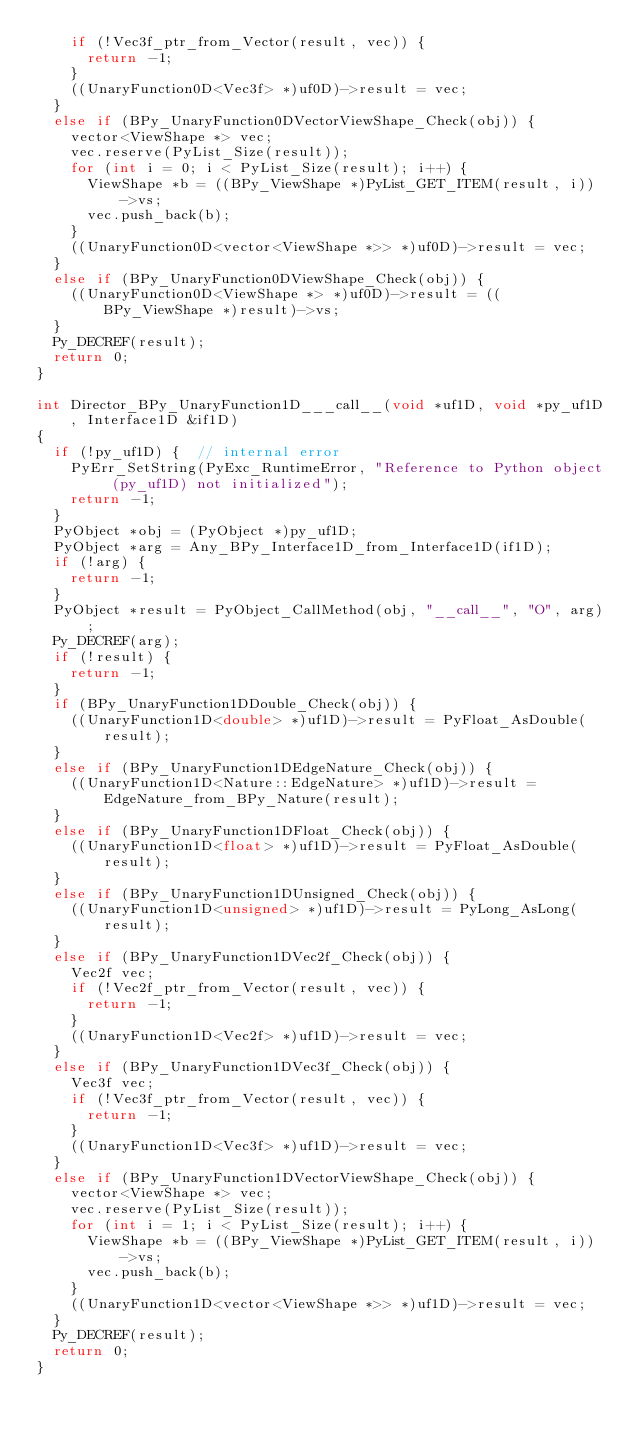<code> <loc_0><loc_0><loc_500><loc_500><_C++_>    if (!Vec3f_ptr_from_Vector(result, vec)) {
      return -1;
    }
    ((UnaryFunction0D<Vec3f> *)uf0D)->result = vec;
  }
  else if (BPy_UnaryFunction0DVectorViewShape_Check(obj)) {
    vector<ViewShape *> vec;
    vec.reserve(PyList_Size(result));
    for (int i = 0; i < PyList_Size(result); i++) {
      ViewShape *b = ((BPy_ViewShape *)PyList_GET_ITEM(result, i))->vs;
      vec.push_back(b);
    }
    ((UnaryFunction0D<vector<ViewShape *>> *)uf0D)->result = vec;
  }
  else if (BPy_UnaryFunction0DViewShape_Check(obj)) {
    ((UnaryFunction0D<ViewShape *> *)uf0D)->result = ((BPy_ViewShape *)result)->vs;
  }
  Py_DECREF(result);
  return 0;
}

int Director_BPy_UnaryFunction1D___call__(void *uf1D, void *py_uf1D, Interface1D &if1D)
{
  if (!py_uf1D) {  // internal error
    PyErr_SetString(PyExc_RuntimeError, "Reference to Python object (py_uf1D) not initialized");
    return -1;
  }
  PyObject *obj = (PyObject *)py_uf1D;
  PyObject *arg = Any_BPy_Interface1D_from_Interface1D(if1D);
  if (!arg) {
    return -1;
  }
  PyObject *result = PyObject_CallMethod(obj, "__call__", "O", arg);
  Py_DECREF(arg);
  if (!result) {
    return -1;
  }
  if (BPy_UnaryFunction1DDouble_Check(obj)) {
    ((UnaryFunction1D<double> *)uf1D)->result = PyFloat_AsDouble(result);
  }
  else if (BPy_UnaryFunction1DEdgeNature_Check(obj)) {
    ((UnaryFunction1D<Nature::EdgeNature> *)uf1D)->result = EdgeNature_from_BPy_Nature(result);
  }
  else if (BPy_UnaryFunction1DFloat_Check(obj)) {
    ((UnaryFunction1D<float> *)uf1D)->result = PyFloat_AsDouble(result);
  }
  else if (BPy_UnaryFunction1DUnsigned_Check(obj)) {
    ((UnaryFunction1D<unsigned> *)uf1D)->result = PyLong_AsLong(result);
  }
  else if (BPy_UnaryFunction1DVec2f_Check(obj)) {
    Vec2f vec;
    if (!Vec2f_ptr_from_Vector(result, vec)) {
      return -1;
    }
    ((UnaryFunction1D<Vec2f> *)uf1D)->result = vec;
  }
  else if (BPy_UnaryFunction1DVec3f_Check(obj)) {
    Vec3f vec;
    if (!Vec3f_ptr_from_Vector(result, vec)) {
      return -1;
    }
    ((UnaryFunction1D<Vec3f> *)uf1D)->result = vec;
  }
  else if (BPy_UnaryFunction1DVectorViewShape_Check(obj)) {
    vector<ViewShape *> vec;
    vec.reserve(PyList_Size(result));
    for (int i = 1; i < PyList_Size(result); i++) {
      ViewShape *b = ((BPy_ViewShape *)PyList_GET_ITEM(result, i))->vs;
      vec.push_back(b);
    }
    ((UnaryFunction1D<vector<ViewShape *>> *)uf1D)->result = vec;
  }
  Py_DECREF(result);
  return 0;
}
</code> 